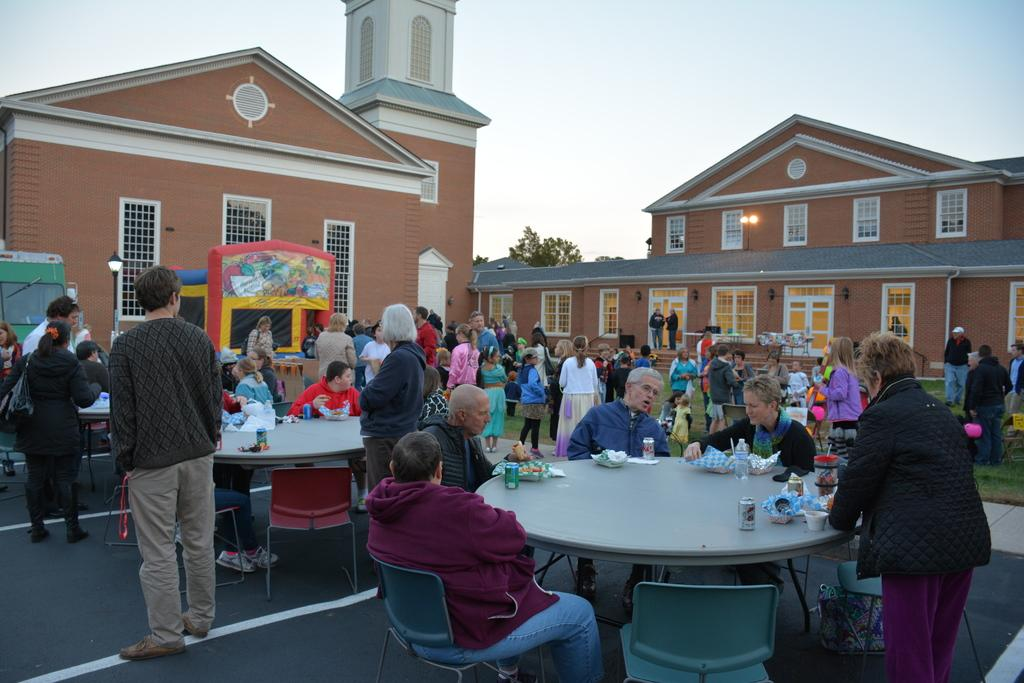How many people are in the image? There are people in the image, but the exact number is not specified. What are some of the people doing in the image? Some of the people are sitting, and some are standing. What can be seen in the background of the image? There are buildings and a tree in the background of the image. What is visible above the people and buildings in the image? The sky is visible in the image. What type of bean is being used as a prop in the image? There is no bean present in the image. How does the wave affect the people in the image? There is no wave present in the image; it is a scene with people, buildings, a tree, and the sky. 